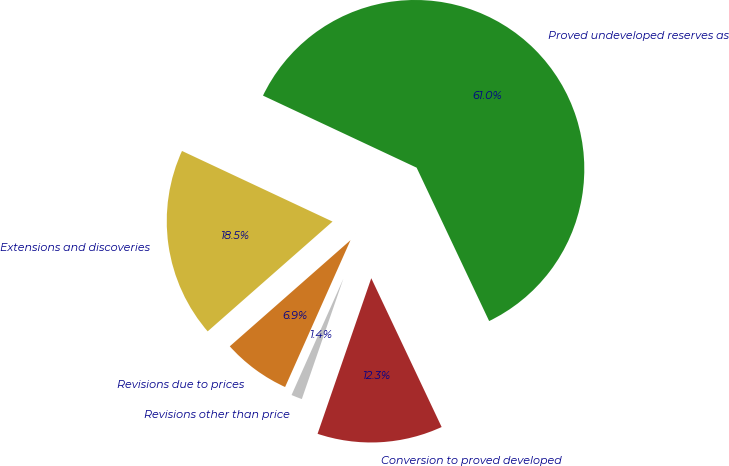Convert chart. <chart><loc_0><loc_0><loc_500><loc_500><pie_chart><fcel>Proved undeveloped reserves as<fcel>Extensions and discoveries<fcel>Revisions due to prices<fcel>Revisions other than price<fcel>Conversion to proved developed<nl><fcel>60.99%<fcel>18.46%<fcel>6.85%<fcel>1.38%<fcel>12.32%<nl></chart> 